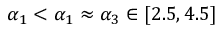Convert formula to latex. <formula><loc_0><loc_0><loc_500><loc_500>\alpha _ { 1 } < \alpha _ { 1 } \approx \alpha _ { 3 } \in [ 2 . 5 , 4 . 5 ]</formula> 